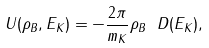Convert formula to latex. <formula><loc_0><loc_0><loc_500><loc_500>U ( \rho _ { B } , E _ { K } ) = - \frac { 2 \pi } { m _ { K } } \rho _ { B } \ D ( E _ { K } ) ,</formula> 